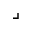<formula> <loc_0><loc_0><loc_500><loc_500>\lrcorner</formula> 